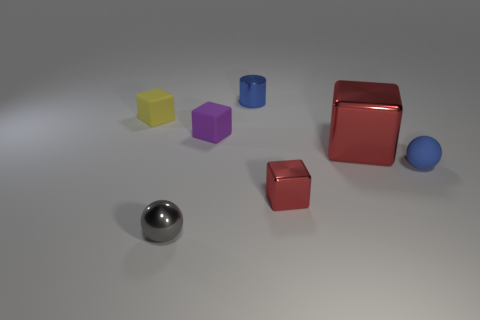Subtract all gray spheres. How many red blocks are left? 2 Subtract all big red shiny cubes. How many cubes are left? 3 Subtract all purple blocks. How many blocks are left? 3 Add 1 blue metal cylinders. How many objects exist? 8 Subtract all cyan cubes. Subtract all brown cylinders. How many cubes are left? 4 Subtract all cylinders. How many objects are left? 6 Subtract all tiny purple blocks. Subtract all small purple rubber blocks. How many objects are left? 5 Add 6 small blocks. How many small blocks are left? 9 Add 1 big gray things. How many big gray things exist? 1 Subtract 0 green cylinders. How many objects are left? 7 